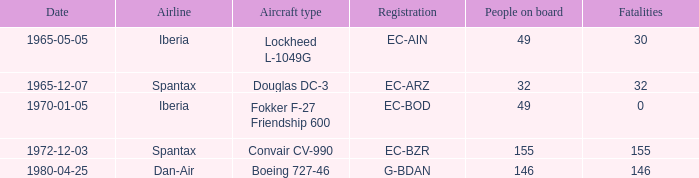What is the number of people on board at Iberia Airline, with the aircraft type of lockheed l-1049g? 49.0. 